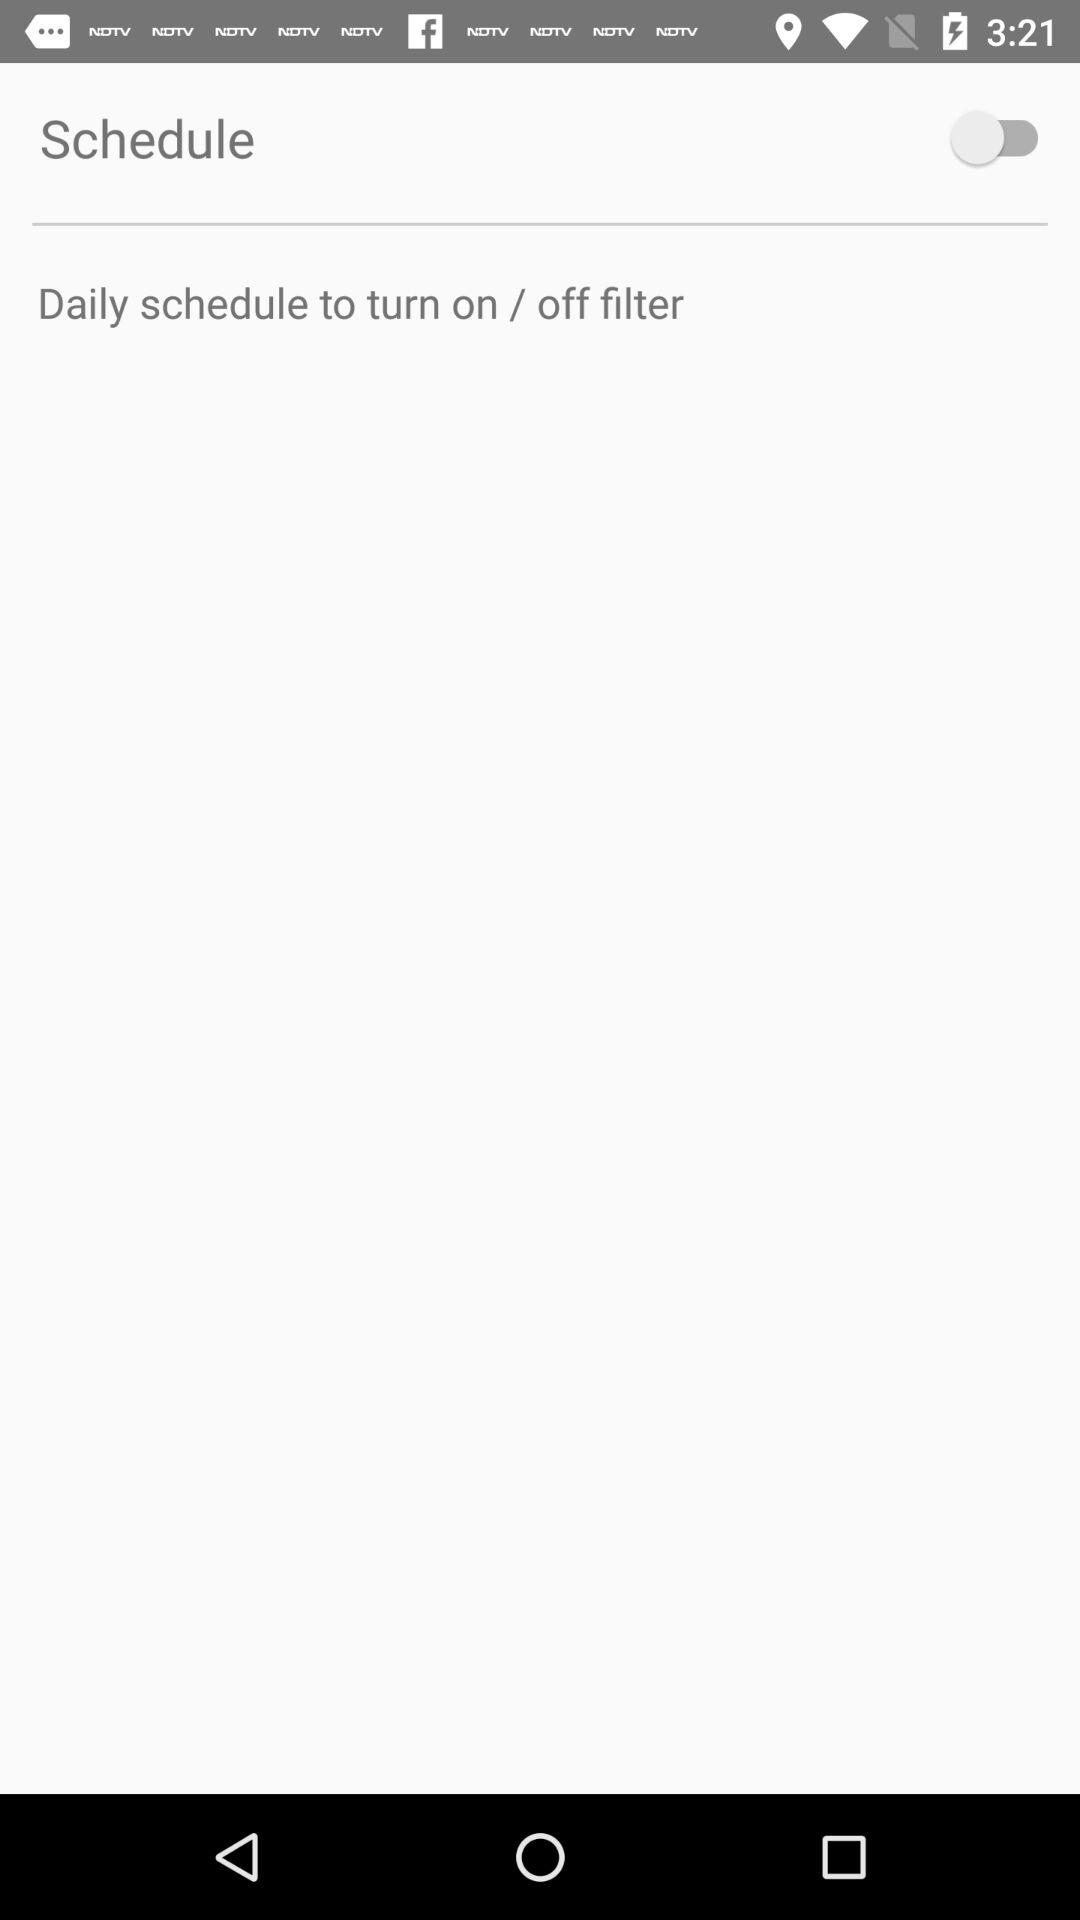What is the setting for "Schedule"? The setting is "off". 